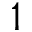Convert formula to latex. <formula><loc_0><loc_0><loc_500><loc_500>1</formula> 